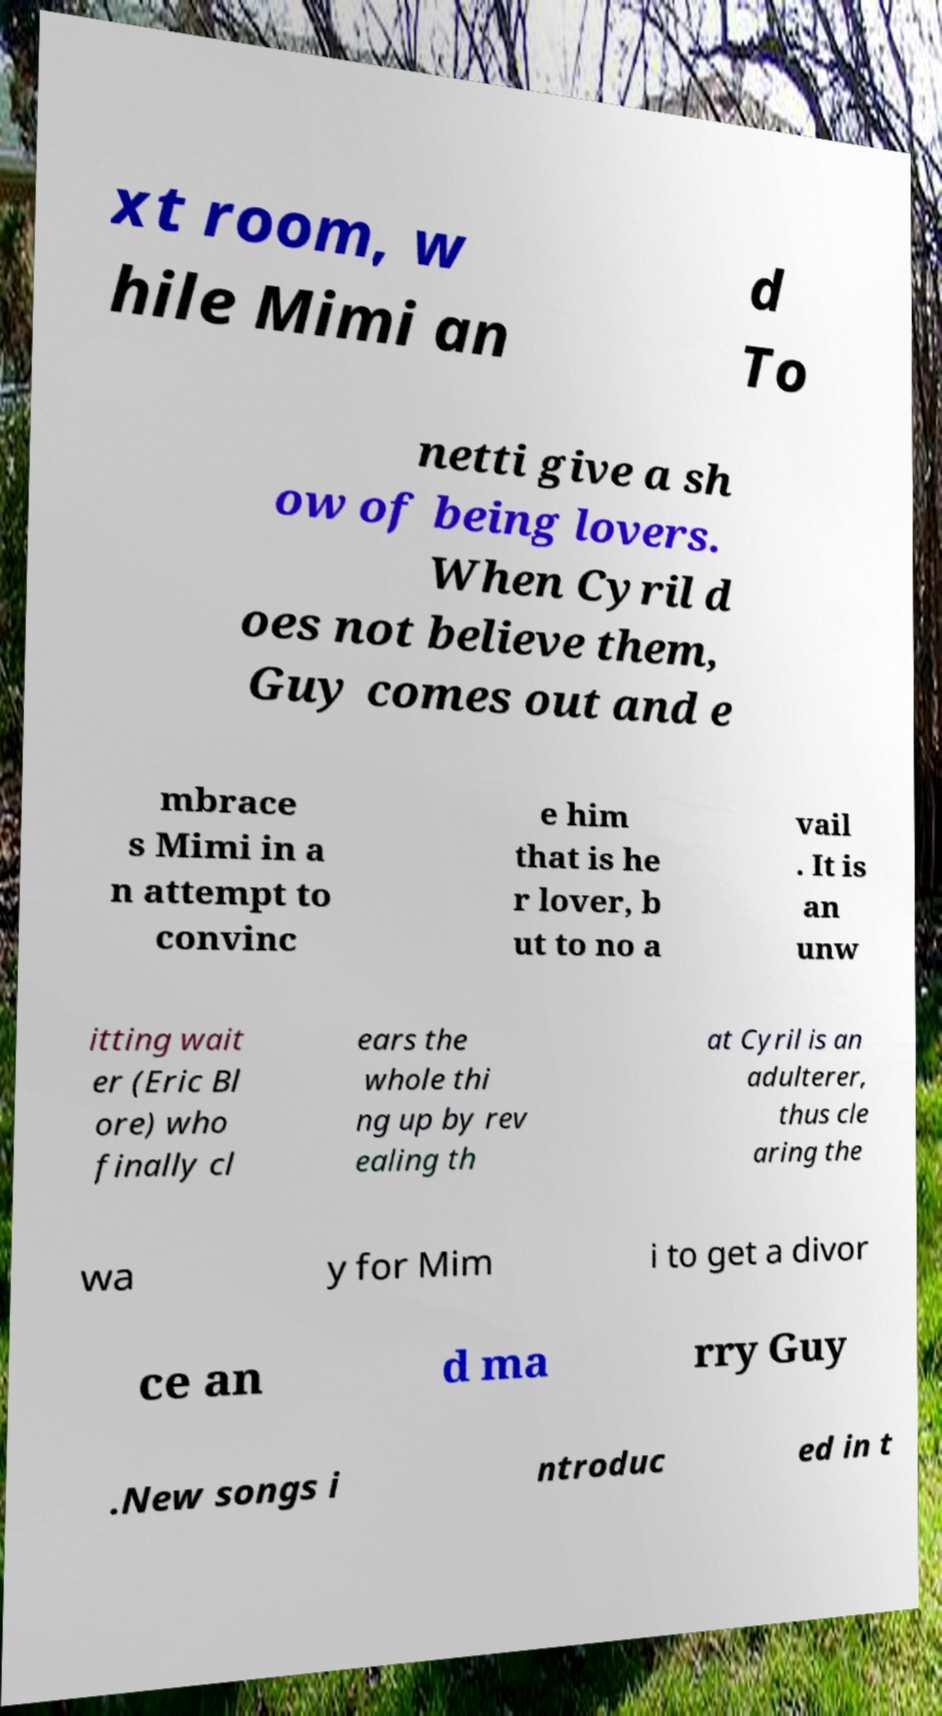Can you accurately transcribe the text from the provided image for me? xt room, w hile Mimi an d To netti give a sh ow of being lovers. When Cyril d oes not believe them, Guy comes out and e mbrace s Mimi in a n attempt to convinc e him that is he r lover, b ut to no a vail . It is an unw itting wait er (Eric Bl ore) who finally cl ears the whole thi ng up by rev ealing th at Cyril is an adulterer, thus cle aring the wa y for Mim i to get a divor ce an d ma rry Guy .New songs i ntroduc ed in t 